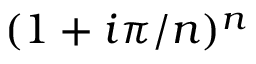<formula> <loc_0><loc_0><loc_500><loc_500>( 1 + i \pi / n ) ^ { n }</formula> 